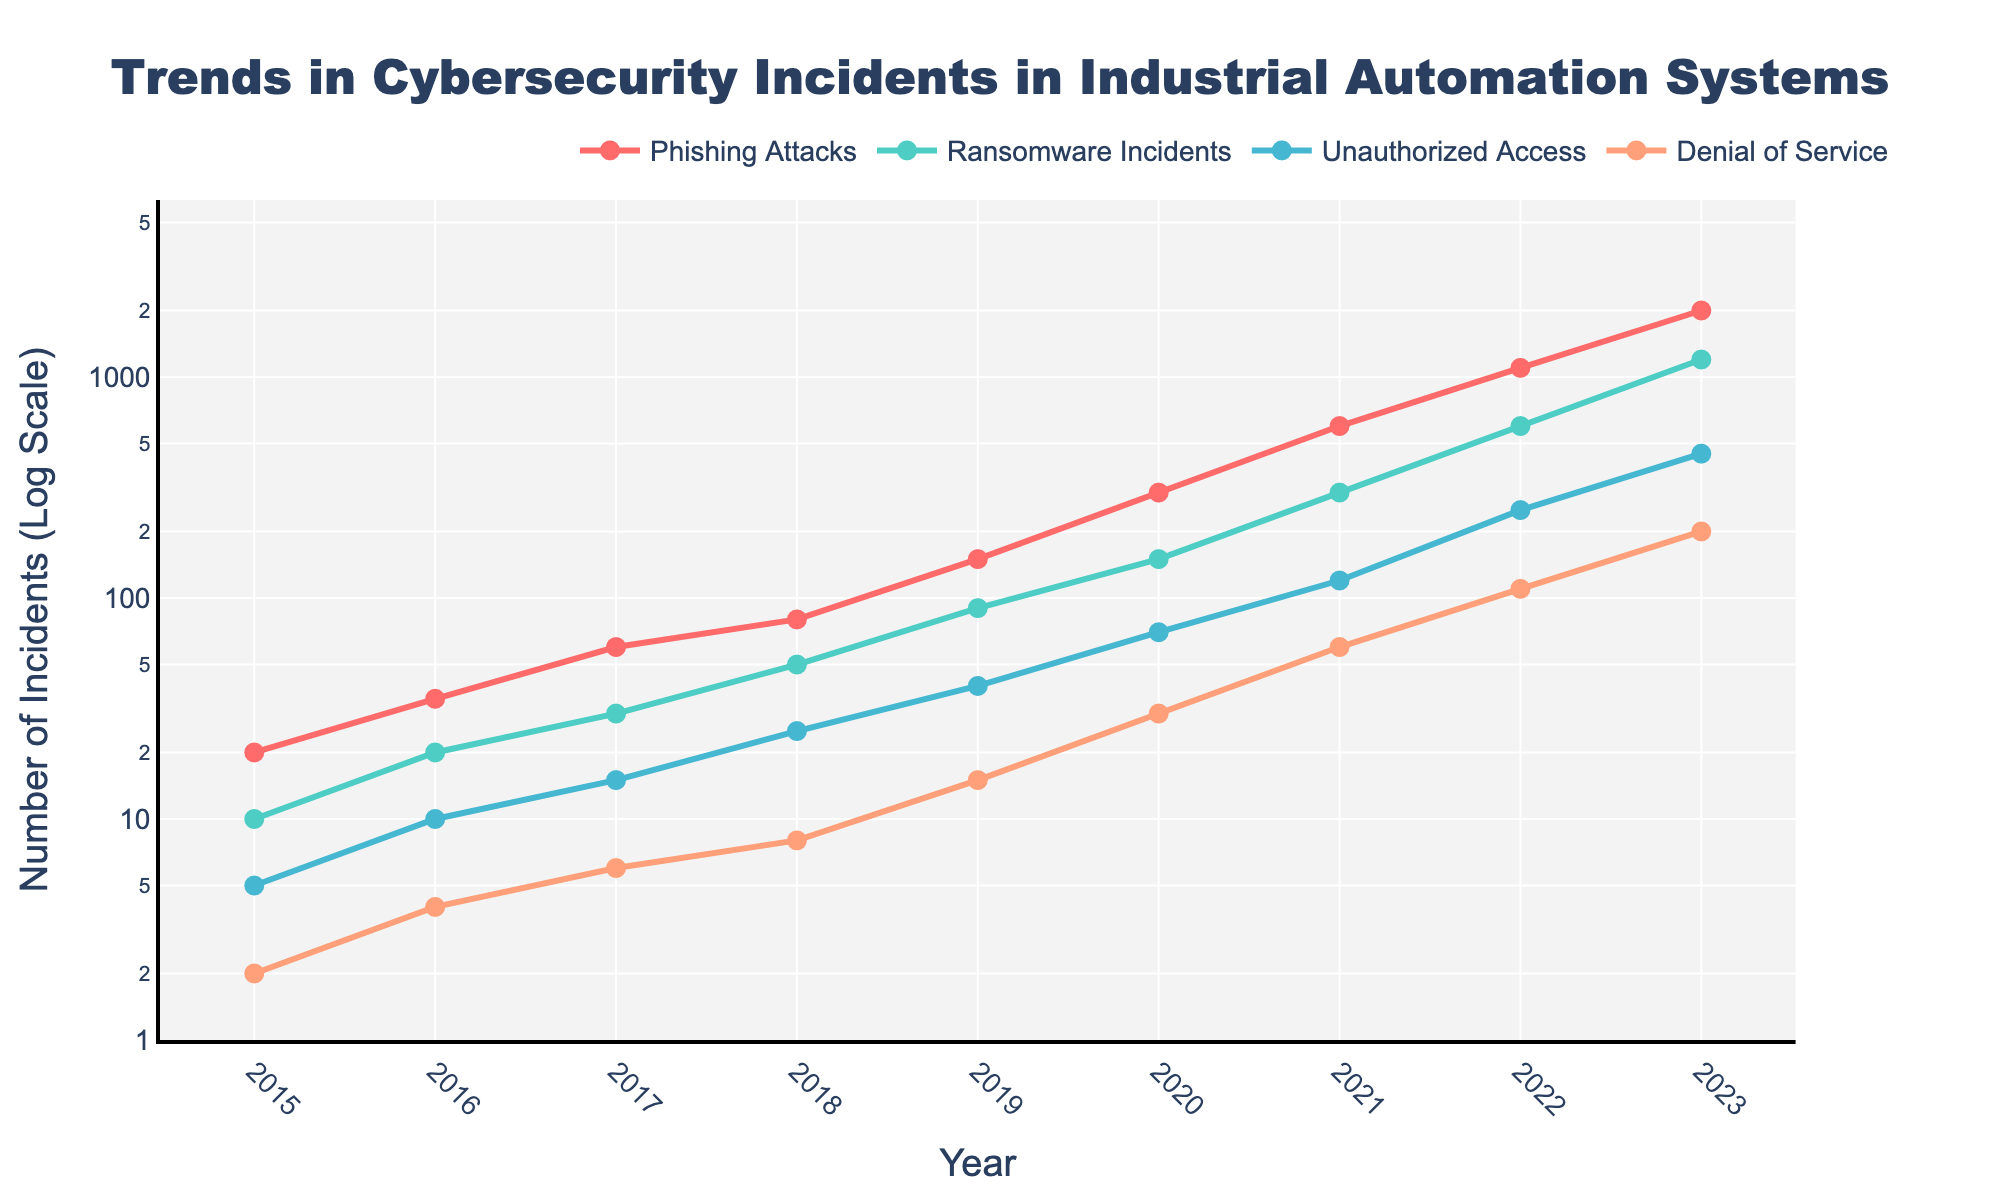What's the title of the figure? The title is generally placed at the top center of the plot and is usually larger and in bold font. The title of the figure clearly states, "Trends in Cybersecurity Incidents in Industrial Automation Systems".
Answer: Trends in Cybersecurity Incidents in Industrial Automation Systems How many types of cybersecurity incidents are tracked in the figure? By looking at the legend on the figure, we can see that four types of incidents are tracked: Phishing Attacks, Ransomware Incidents, Unauthorized Access, and Denial of Service.
Answer: Four What is the y-axis scale for the number of incidents? The y-axis title states "Number of Incidents (Log Scale)", indicating that the scale used is logarithmic, not linear.
Answer: Logarithmic scale Which year saw the highest number of phishing attacks? By examining the plot specifically at the points for Phishing Attacks, the highest value is located at the point corresponding to the year 2023.
Answer: 2023 How did the number of ransomware incidents change from 2015 to 2023? Observing the trendline for ransomware incidents, it starts at 10 in 2015 and increases significantly to 1200 by 2023. The difference can be calculated as 1200 - 10.
Answer: Increased by 1190 Between 2018 and 2021, which incident type had the steepest increase? By comparing the slopes of the lines from 2018 to 2021, phishing attacks show the steepest increase from approximately 80 to 600, compared to the other incident types.
Answer: Phishing Attacks In what year did the number of unauthorized access incidents exceed 100? Looking at the Unauthorized Access trend, the point exceeds 100 in the year 2022.
Answer: 2022 What is the range of years covered in the figure? The x-axis starts at 2015 and ends at 2023, indicating an 8-year range.
Answer: From 2015 to 2023 Which year shows a significant jump in denial of service incidents from the previous year? There is considerable growth between 2021 and 2022, where the incidents surged from 60 to 110.
Answer: 2022 What can you infer about the overall trend of cybersecurity incidents from 2015 to 2023? All incident types demonstrate a sharp upward trend over the years, with incidents generally increasing exponentially, as shown on the log scale y-axis.
Answer: Increasing exponentially 